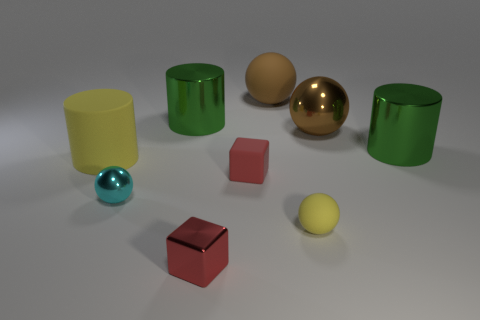What is the cyan ball made of?
Make the answer very short. Metal. Are there the same number of yellow matte spheres that are behind the brown metallic object and small brown cylinders?
Offer a terse response. Yes. How many other things have the same shape as the big brown metal object?
Provide a succinct answer. 3. Does the red rubber object have the same shape as the red shiny object?
Make the answer very short. Yes. How many objects are small yellow objects that are right of the tiny red metal object or balls?
Your answer should be compact. 4. What is the shape of the large matte object to the left of the big metallic cylinder that is to the left of the red object behind the small cyan ball?
Your answer should be compact. Cylinder. What is the shape of the large yellow thing that is made of the same material as the tiny yellow thing?
Your answer should be compact. Cylinder. The cyan sphere has what size?
Ensure brevity in your answer.  Small. Is the red rubber cube the same size as the brown metal thing?
Your answer should be compact. No. What number of things are brown spheres right of the big brown matte ball or small metallic cubes in front of the brown metal ball?
Offer a terse response. 2. 